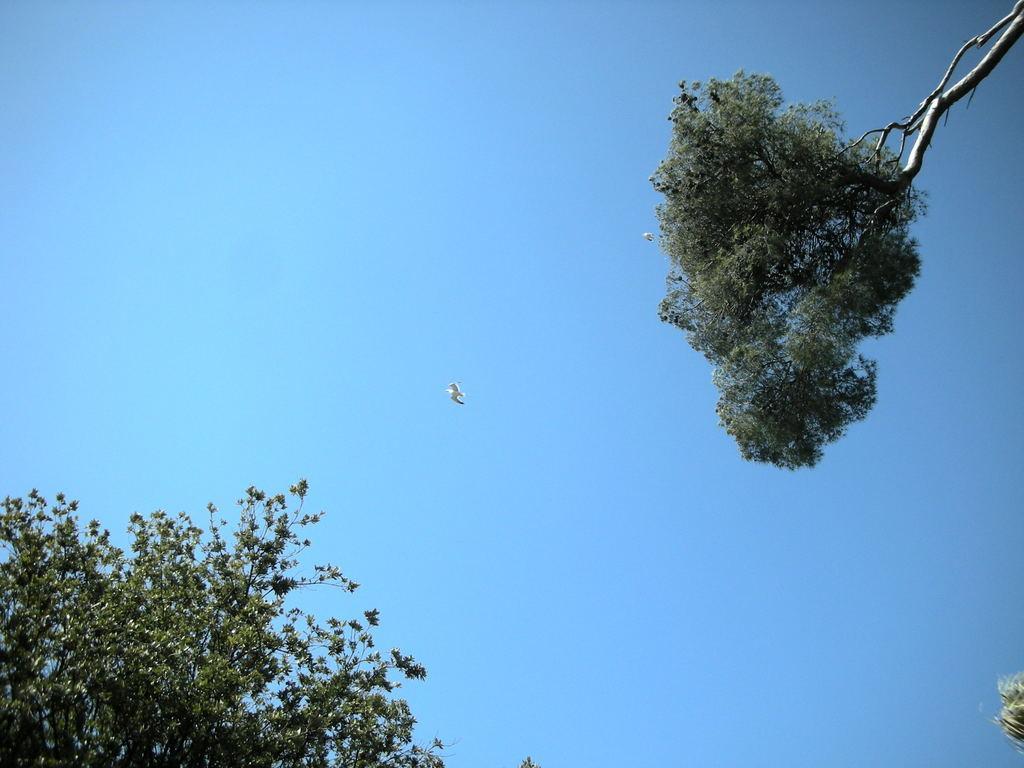In one or two sentences, can you explain what this image depicts? In the center of the image there is a bird in the sky. At the top right corner and bottom left corner we can see trees. 